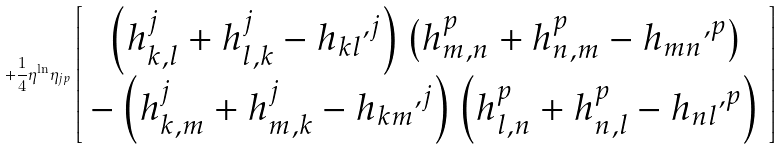<formula> <loc_0><loc_0><loc_500><loc_500>+ \frac { 1 } { 4 } \eta ^ { \ln } \eta _ { j p } \left [ \begin{array} { c } \left ( h ^ { j } _ { k , l } + h ^ { j } _ { l , k } - { h _ { k l } } ^ { , j } \right ) \left ( h ^ { p } _ { m , n } + h ^ { p } _ { n , m } - { h _ { m n } } ^ { , p } \right ) \\ - \left ( h ^ { j } _ { k , m } + h ^ { j } _ { m , k } - { h _ { k m } } ^ { , j } \right ) \left ( h ^ { p } _ { l , n } + h ^ { p } _ { n , l } - { h _ { n l } } ^ { , p } \right ) \end{array} \right ]</formula> 